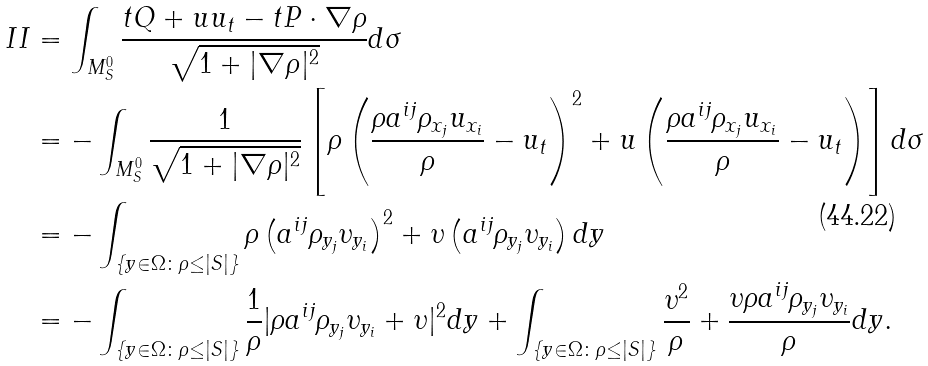Convert formula to latex. <formula><loc_0><loc_0><loc_500><loc_500>I I & = \int _ { M _ { S } ^ { 0 } } \frac { t Q + u u _ { t } - t P \cdot \nabla \rho } { \sqrt { 1 + | \nabla \rho | ^ { 2 } } } d \sigma \\ & = - \int _ { M _ { S } ^ { 0 } } \frac { 1 } { \sqrt { 1 + | \nabla \rho | ^ { 2 } } } \left [ \rho \left ( \frac { \rho a ^ { i j } \rho _ { x _ { j } } u _ { x _ { i } } } { \rho } - u _ { t } \right ) ^ { 2 } + u \left ( \frac { \rho a ^ { i j } \rho _ { x _ { j } } u _ { x _ { i } } } { \rho } - u _ { t } \right ) \right ] d \sigma \\ & = - \int _ { \{ y \in \Omega \colon \rho \leq | S | \} } \rho \left ( a ^ { i j } \rho _ { y _ { j } } \upsilon _ { y _ { i } } \right ) ^ { 2 } + \upsilon \left ( a ^ { i j } \rho _ { y _ { j } } \upsilon _ { y _ { i } } \right ) d y \\ & = - \int _ { \{ y \in \Omega \colon \rho \leq | S | \} } \frac { 1 } { \rho } | \rho a ^ { i j } \rho _ { y _ { j } } \upsilon _ { y _ { i } } + \upsilon | ^ { 2 } d y + \int _ { \{ y \in \Omega \colon \rho \leq | S | \} } \frac { \upsilon ^ { 2 } } { \rho } + \frac { \upsilon \rho a ^ { i j } \rho _ { y _ { j } } \upsilon _ { y _ { i } } } { \rho } d y . \\</formula> 